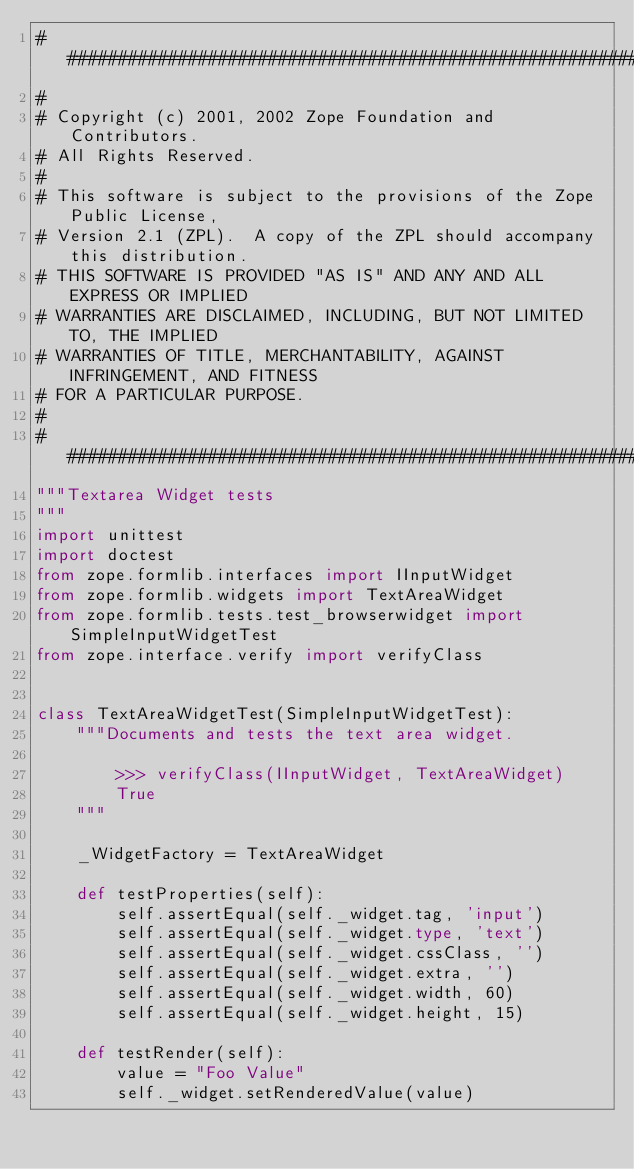<code> <loc_0><loc_0><loc_500><loc_500><_Python_>##############################################################################
#
# Copyright (c) 2001, 2002 Zope Foundation and Contributors.
# All Rights Reserved.
#
# This software is subject to the provisions of the Zope Public License,
# Version 2.1 (ZPL).  A copy of the ZPL should accompany this distribution.
# THIS SOFTWARE IS PROVIDED "AS IS" AND ANY AND ALL EXPRESS OR IMPLIED
# WARRANTIES ARE DISCLAIMED, INCLUDING, BUT NOT LIMITED TO, THE IMPLIED
# WARRANTIES OF TITLE, MERCHANTABILITY, AGAINST INFRINGEMENT, AND FITNESS
# FOR A PARTICULAR PURPOSE.
#
##############################################################################
"""Textarea Widget tests
"""
import unittest
import doctest
from zope.formlib.interfaces import IInputWidget
from zope.formlib.widgets import TextAreaWidget
from zope.formlib.tests.test_browserwidget import SimpleInputWidgetTest
from zope.interface.verify import verifyClass


class TextAreaWidgetTest(SimpleInputWidgetTest):
    """Documents and tests the text area widget.

        >>> verifyClass(IInputWidget, TextAreaWidget)
        True
    """

    _WidgetFactory = TextAreaWidget

    def testProperties(self):
        self.assertEqual(self._widget.tag, 'input')
        self.assertEqual(self._widget.type, 'text')
        self.assertEqual(self._widget.cssClass, '')
        self.assertEqual(self._widget.extra, '')
        self.assertEqual(self._widget.width, 60)
        self.assertEqual(self._widget.height, 15)

    def testRender(self):
        value = "Foo Value"
        self._widget.setRenderedValue(value)</code> 